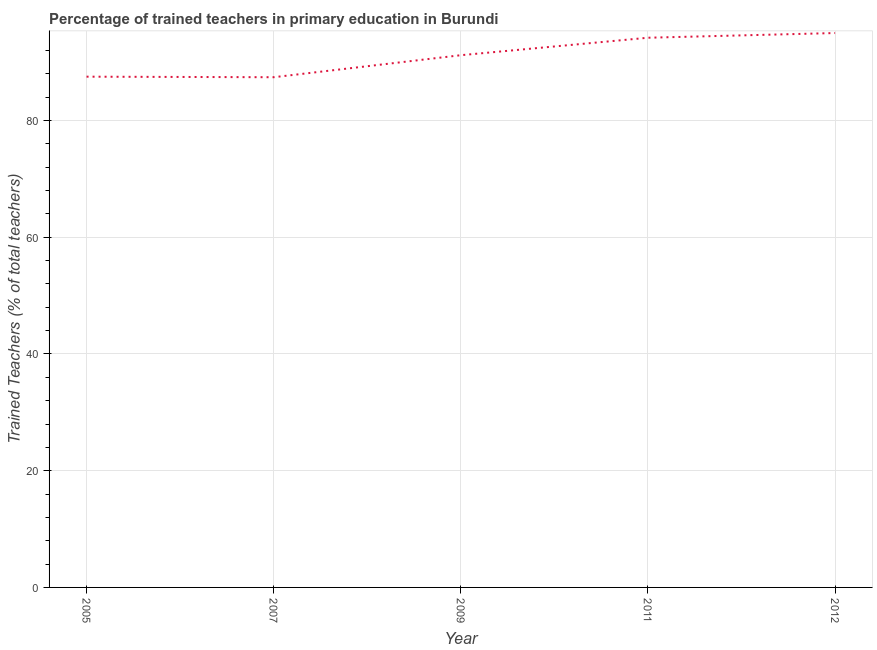What is the percentage of trained teachers in 2012?
Give a very brief answer. 94.99. Across all years, what is the maximum percentage of trained teachers?
Give a very brief answer. 94.99. Across all years, what is the minimum percentage of trained teachers?
Give a very brief answer. 87.42. In which year was the percentage of trained teachers minimum?
Give a very brief answer. 2007. What is the sum of the percentage of trained teachers?
Provide a succinct answer. 455.28. What is the difference between the percentage of trained teachers in 2005 and 2009?
Offer a terse response. -3.68. What is the average percentage of trained teachers per year?
Provide a short and direct response. 91.06. What is the median percentage of trained teachers?
Make the answer very short. 91.19. What is the ratio of the percentage of trained teachers in 2005 to that in 2007?
Offer a very short reply. 1. Is the percentage of trained teachers in 2011 less than that in 2012?
Ensure brevity in your answer.  Yes. What is the difference between the highest and the second highest percentage of trained teachers?
Your answer should be very brief. 0.81. Is the sum of the percentage of trained teachers in 2011 and 2012 greater than the maximum percentage of trained teachers across all years?
Make the answer very short. Yes. What is the difference between the highest and the lowest percentage of trained teachers?
Your answer should be very brief. 7.57. In how many years, is the percentage of trained teachers greater than the average percentage of trained teachers taken over all years?
Your answer should be compact. 3. How many years are there in the graph?
Keep it short and to the point. 5. What is the difference between two consecutive major ticks on the Y-axis?
Ensure brevity in your answer.  20. Are the values on the major ticks of Y-axis written in scientific E-notation?
Give a very brief answer. No. Does the graph contain grids?
Your answer should be very brief. Yes. What is the title of the graph?
Your answer should be very brief. Percentage of trained teachers in primary education in Burundi. What is the label or title of the X-axis?
Ensure brevity in your answer.  Year. What is the label or title of the Y-axis?
Offer a very short reply. Trained Teachers (% of total teachers). What is the Trained Teachers (% of total teachers) of 2005?
Your answer should be very brief. 87.51. What is the Trained Teachers (% of total teachers) of 2007?
Keep it short and to the point. 87.42. What is the Trained Teachers (% of total teachers) in 2009?
Offer a very short reply. 91.19. What is the Trained Teachers (% of total teachers) in 2011?
Your response must be concise. 94.18. What is the Trained Teachers (% of total teachers) in 2012?
Your answer should be very brief. 94.99. What is the difference between the Trained Teachers (% of total teachers) in 2005 and 2007?
Your answer should be compact. 0.09. What is the difference between the Trained Teachers (% of total teachers) in 2005 and 2009?
Give a very brief answer. -3.68. What is the difference between the Trained Teachers (% of total teachers) in 2005 and 2011?
Give a very brief answer. -6.67. What is the difference between the Trained Teachers (% of total teachers) in 2005 and 2012?
Offer a terse response. -7.48. What is the difference between the Trained Teachers (% of total teachers) in 2007 and 2009?
Keep it short and to the point. -3.77. What is the difference between the Trained Teachers (% of total teachers) in 2007 and 2011?
Provide a succinct answer. -6.77. What is the difference between the Trained Teachers (% of total teachers) in 2007 and 2012?
Offer a very short reply. -7.57. What is the difference between the Trained Teachers (% of total teachers) in 2009 and 2011?
Give a very brief answer. -2.99. What is the difference between the Trained Teachers (% of total teachers) in 2009 and 2012?
Give a very brief answer. -3.8. What is the difference between the Trained Teachers (% of total teachers) in 2011 and 2012?
Offer a very short reply. -0.81. What is the ratio of the Trained Teachers (% of total teachers) in 2005 to that in 2007?
Your answer should be very brief. 1. What is the ratio of the Trained Teachers (% of total teachers) in 2005 to that in 2011?
Ensure brevity in your answer.  0.93. What is the ratio of the Trained Teachers (% of total teachers) in 2005 to that in 2012?
Your answer should be very brief. 0.92. What is the ratio of the Trained Teachers (% of total teachers) in 2007 to that in 2009?
Provide a short and direct response. 0.96. What is the ratio of the Trained Teachers (% of total teachers) in 2007 to that in 2011?
Offer a very short reply. 0.93. What is the ratio of the Trained Teachers (% of total teachers) in 2011 to that in 2012?
Provide a short and direct response. 0.99. 